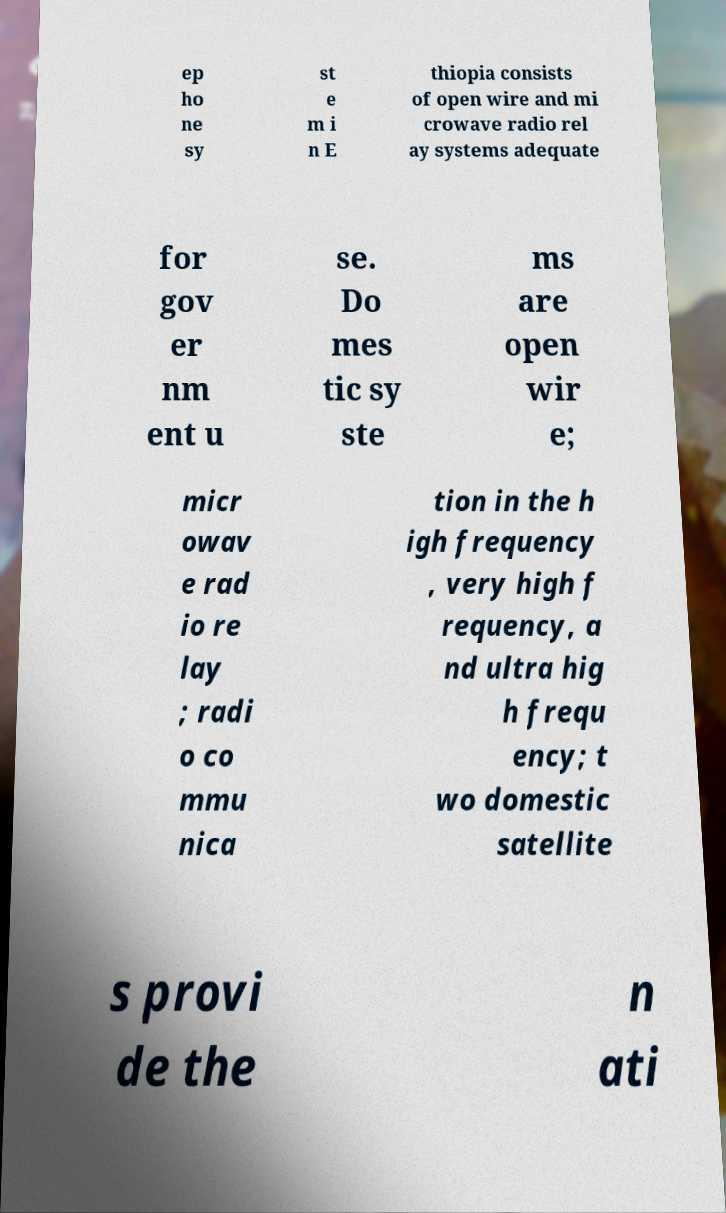I need the written content from this picture converted into text. Can you do that? ep ho ne sy st e m i n E thiopia consists of open wire and mi crowave radio rel ay systems adequate for gov er nm ent u se. Do mes tic sy ste ms are open wir e; micr owav e rad io re lay ; radi o co mmu nica tion in the h igh frequency , very high f requency, a nd ultra hig h frequ ency; t wo domestic satellite s provi de the n ati 